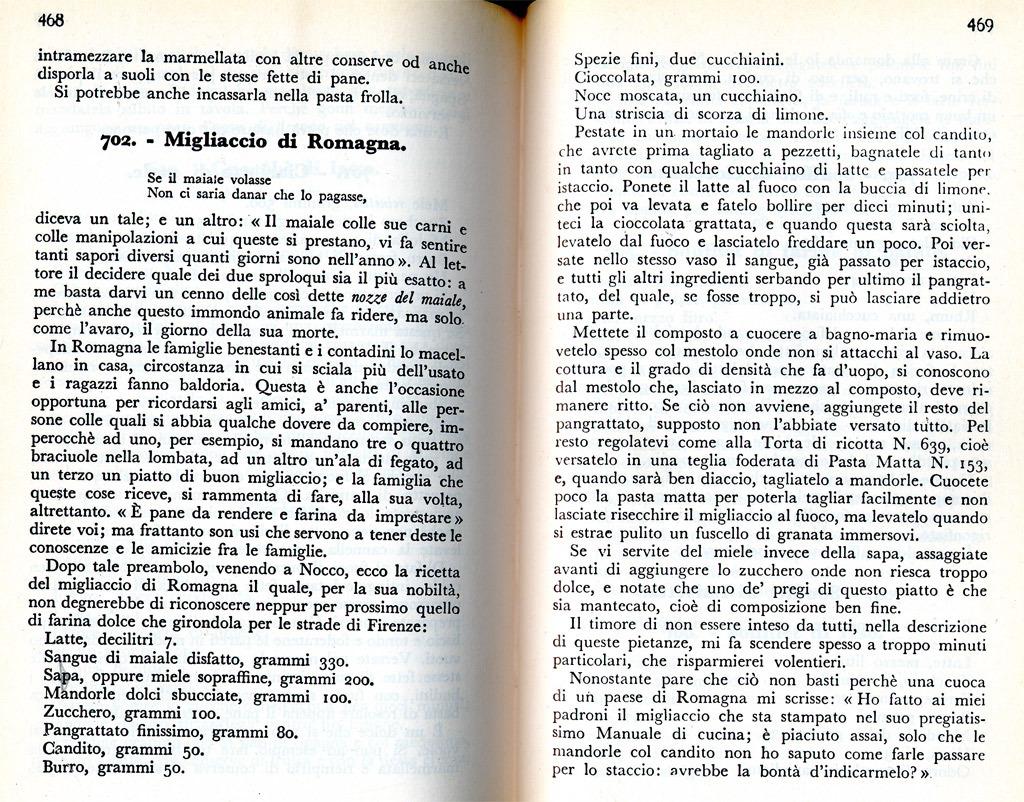What are the page numbers shown here?
Keep it short and to the point. 468 and 469. What is wrote on the first line of the book?
Provide a succinct answer. Intramezzare. 